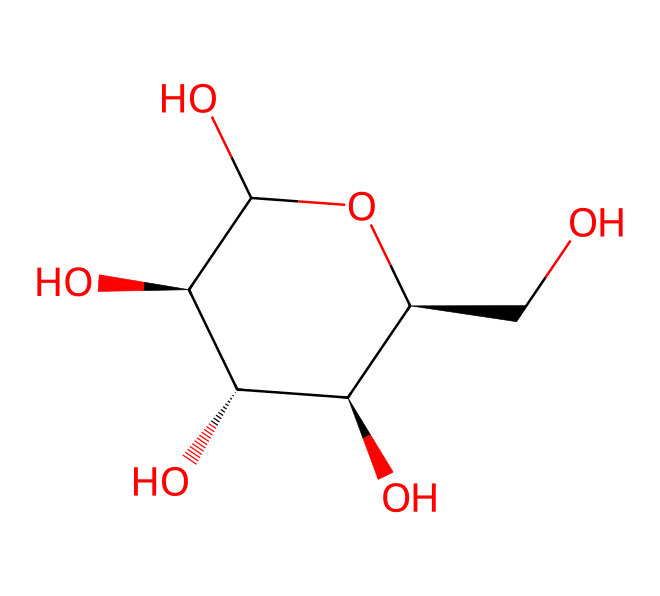How many carbon atoms are present in this structure? By examining the SMILES notation, we can see the number of carbon atoms represented. In the SMILES, "C" denotes carbon atoms. Counting the occurrences of "C", we find there are 6 carbon atoms in total.
Answer: six What is the molecular formula of the compound represented? To find the molecular formula, we need to identify the number of each type of atom present. From the structure, we find 6 carbon, 12 hydrogen, and 6 oxygen atoms, leading to the molecular formula C6H12O6.
Answer: C6H12O6 What type of organic compound does this chemical represent? The chemical structure resembles that of a sugar molecule, specifically a hexose, which is a simple carbohydrate. This is determined by the ring structure and multiple hydroxyl (-OH) groups present.
Answer: sugar What functional groups are present in this compound? The presence of multiple hydroxyl (-OH) groups indicates that this compound has alcoholic functional groups. We can identify them in the structure based on the -OH attachments associated with carbon atoms.
Answer: hydroxyl groups Is this compound likely to be soluble in water? Given that this compound contains several hydroxyl groups, which are hydrophilic, it indicates that the compound is likely to be soluble in water. The numerous polar groups facilitate hydrogen bonding with water.
Answer: yes What is the stereochemistry of this compound? The stereochemistry can be determined by looking for chiral centers in the structure. Each carbon atom that is bonded to four different substituents is considered a chiral center, which we see represented by "@" signs in the SMILES. The compound contains multiple chiral centers.
Answer: multiple chiral centers 